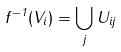<formula> <loc_0><loc_0><loc_500><loc_500>f ^ { - 1 } ( V _ { i } ) = \bigcup _ { j } U _ { i j }</formula> 